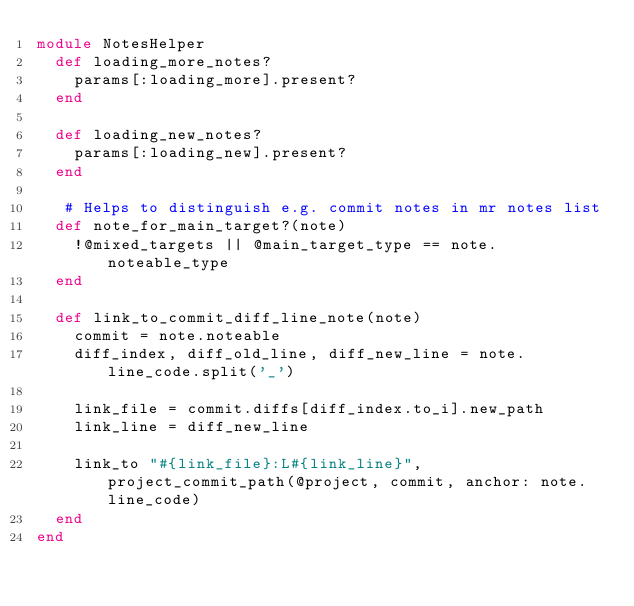Convert code to text. <code><loc_0><loc_0><loc_500><loc_500><_Ruby_>module NotesHelper
  def loading_more_notes?
    params[:loading_more].present?
  end

  def loading_new_notes?
    params[:loading_new].present?
  end

   # Helps to distinguish e.g. commit notes in mr notes list
  def note_for_main_target?(note)
    !@mixed_targets || @main_target_type == note.noteable_type
  end

  def link_to_commit_diff_line_note(note)
    commit = note.noteable
    diff_index, diff_old_line, diff_new_line = note.line_code.split('_')

    link_file = commit.diffs[diff_index.to_i].new_path
    link_line = diff_new_line

    link_to "#{link_file}:L#{link_line}", project_commit_path(@project, commit, anchor: note.line_code)
  end
end
</code> 